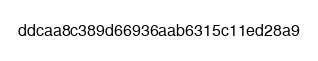Convert code to text. <code><loc_0><loc_0><loc_500><loc_500><_SML_>ddcaa8c389d66936aab6315c11ed28a9</code> 